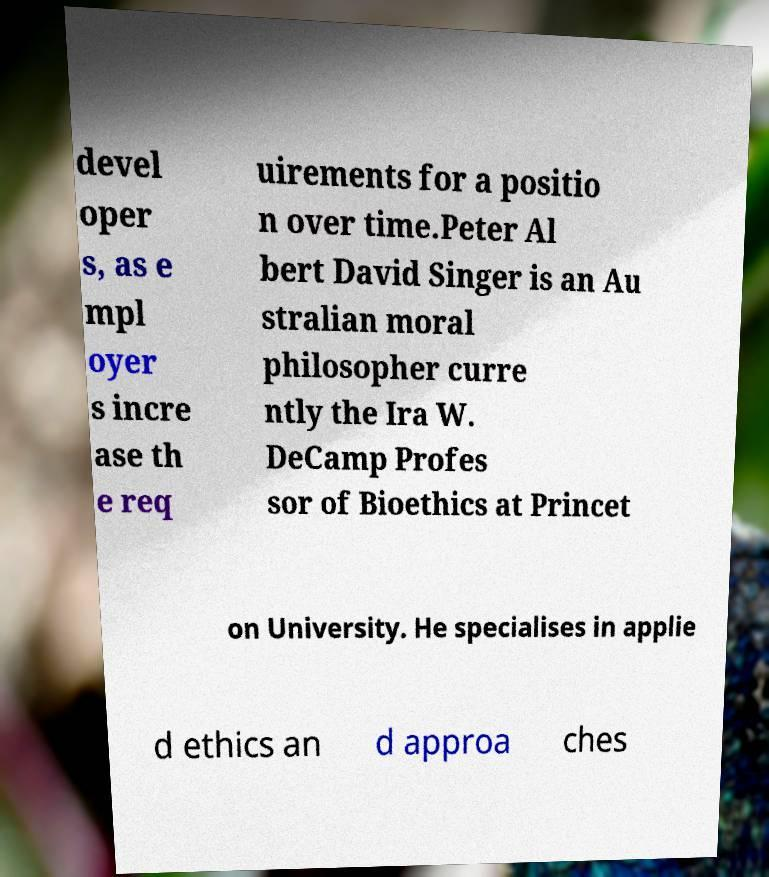Please identify and transcribe the text found in this image. devel oper s, as e mpl oyer s incre ase th e req uirements for a positio n over time.Peter Al bert David Singer is an Au stralian moral philosopher curre ntly the Ira W. DeCamp Profes sor of Bioethics at Princet on University. He specialises in applie d ethics an d approa ches 